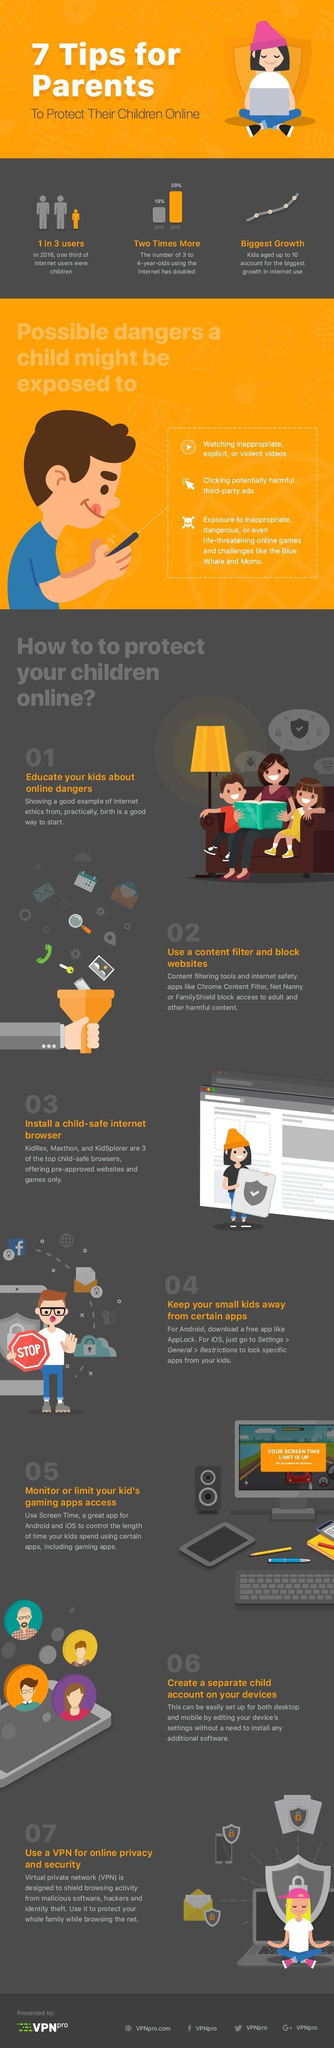By what percent did the number of 3 to 4 year olds using the internet increase from 2010 to 2015?
Answer the question with a short phrase. 20% Which is the Facebook profile given? VPNpro What is the Twitter handle given? VPNpro In 2016, how many internet users were not children? 2 in 3 